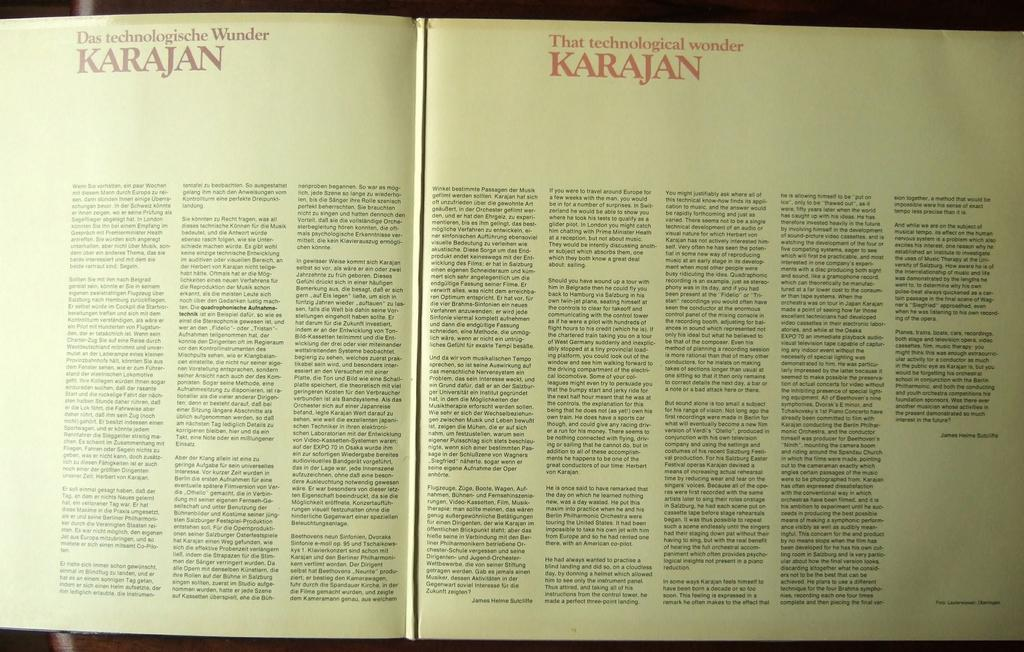<image>
Offer a succinct explanation of the picture presented. A book is open and the word Karajan is on the top of both pages. 